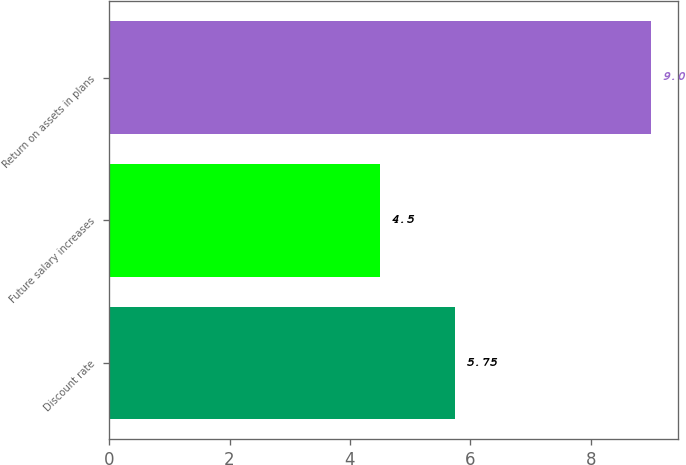<chart> <loc_0><loc_0><loc_500><loc_500><bar_chart><fcel>Discount rate<fcel>Future salary increases<fcel>Return on assets in plans<nl><fcel>5.75<fcel>4.5<fcel>9<nl></chart> 